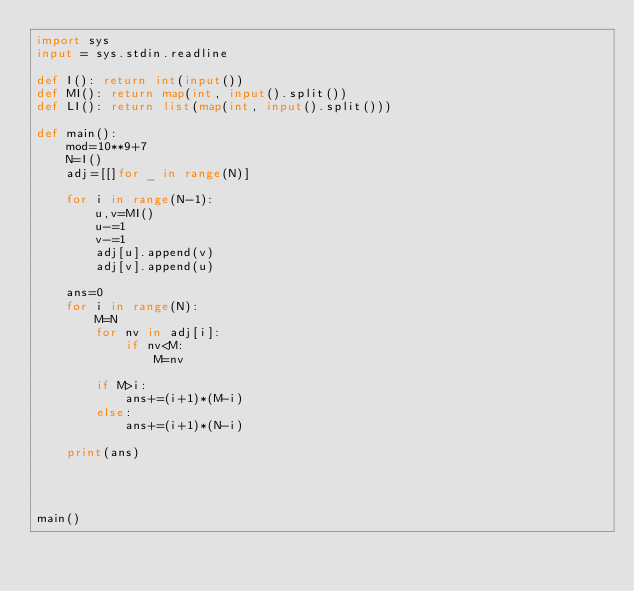Convert code to text. <code><loc_0><loc_0><loc_500><loc_500><_Python_>import sys
input = sys.stdin.readline

def I(): return int(input())
def MI(): return map(int, input().split())
def LI(): return list(map(int, input().split()))

def main():
    mod=10**9+7
    N=I()
    adj=[[]for _ in range(N)]
    
    for i in range(N-1):
        u,v=MI()
        u-=1
        v-=1
        adj[u].append(v)
        adj[v].append(u)
        
    ans=0
    for i in range(N):
        M=N
        for nv in adj[i]:
            if nv<M:
                M=nv
                
        if M>i:
            ans+=(i+1)*(M-i)
        else:
            ans+=(i+1)*(N-i)
        
    print(ans)
                
        
    

main()
</code> 